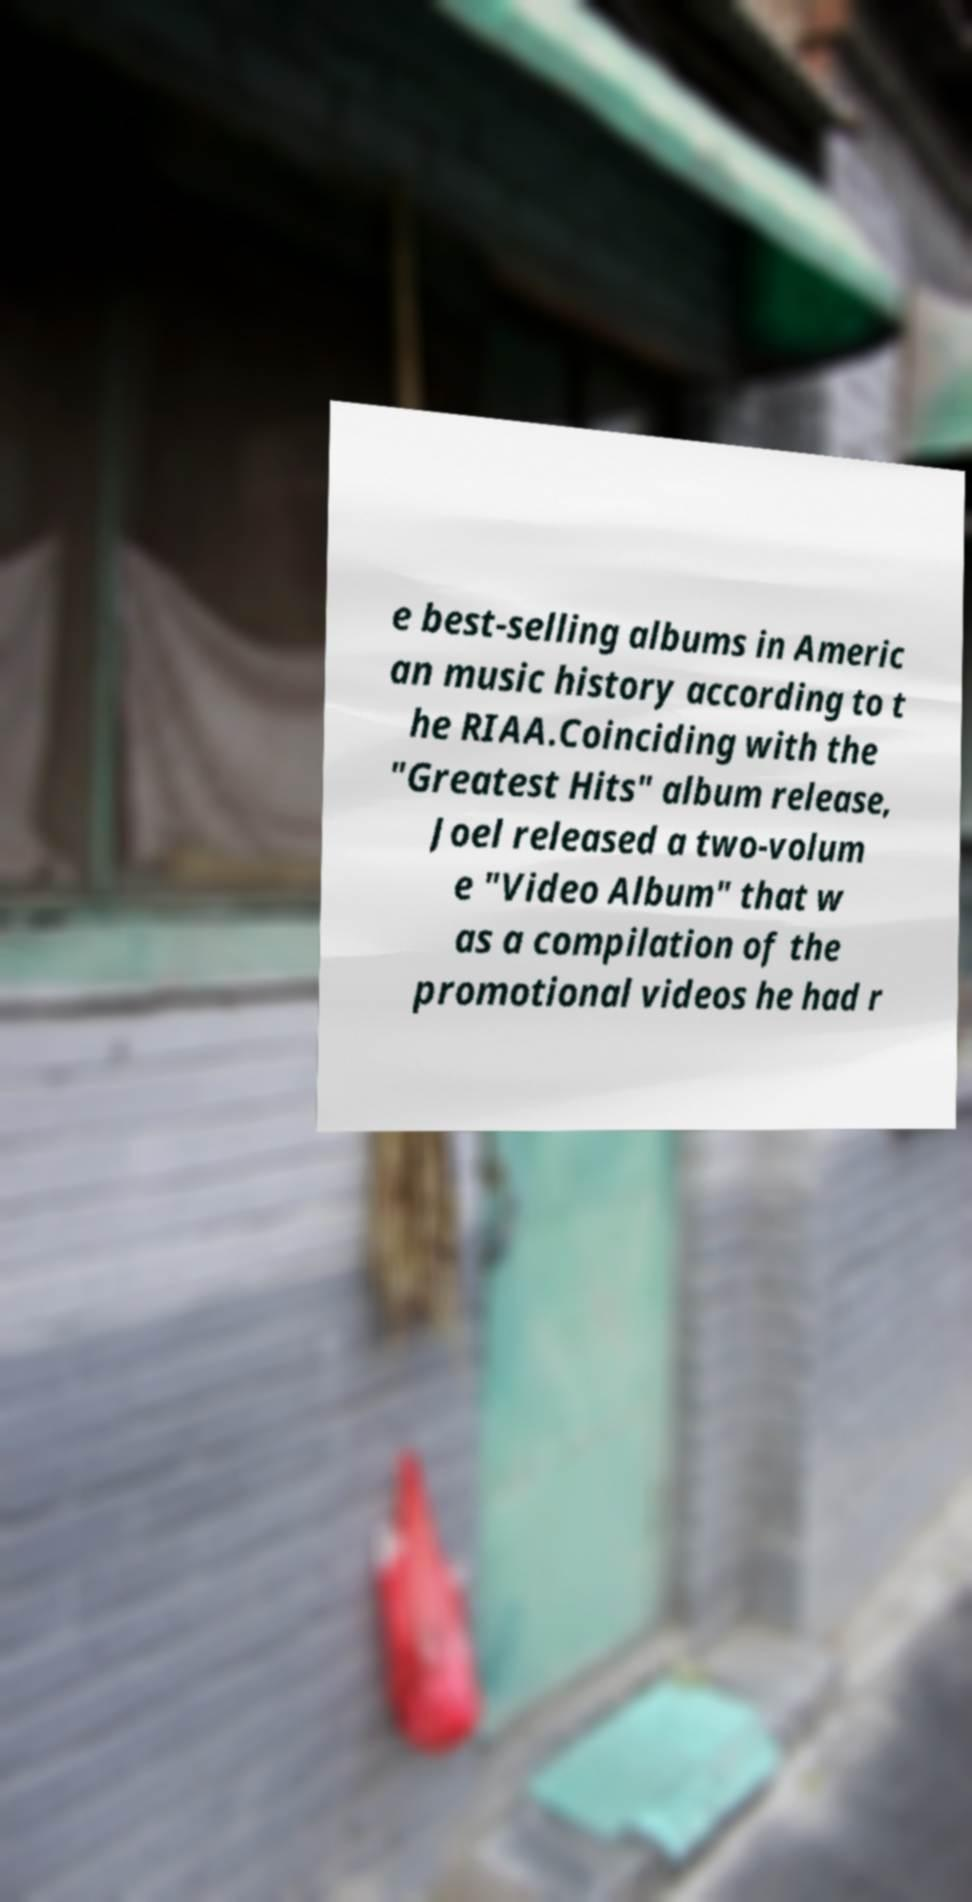Please identify and transcribe the text found in this image. e best-selling albums in Americ an music history according to t he RIAA.Coinciding with the "Greatest Hits" album release, Joel released a two-volum e "Video Album" that w as a compilation of the promotional videos he had r 